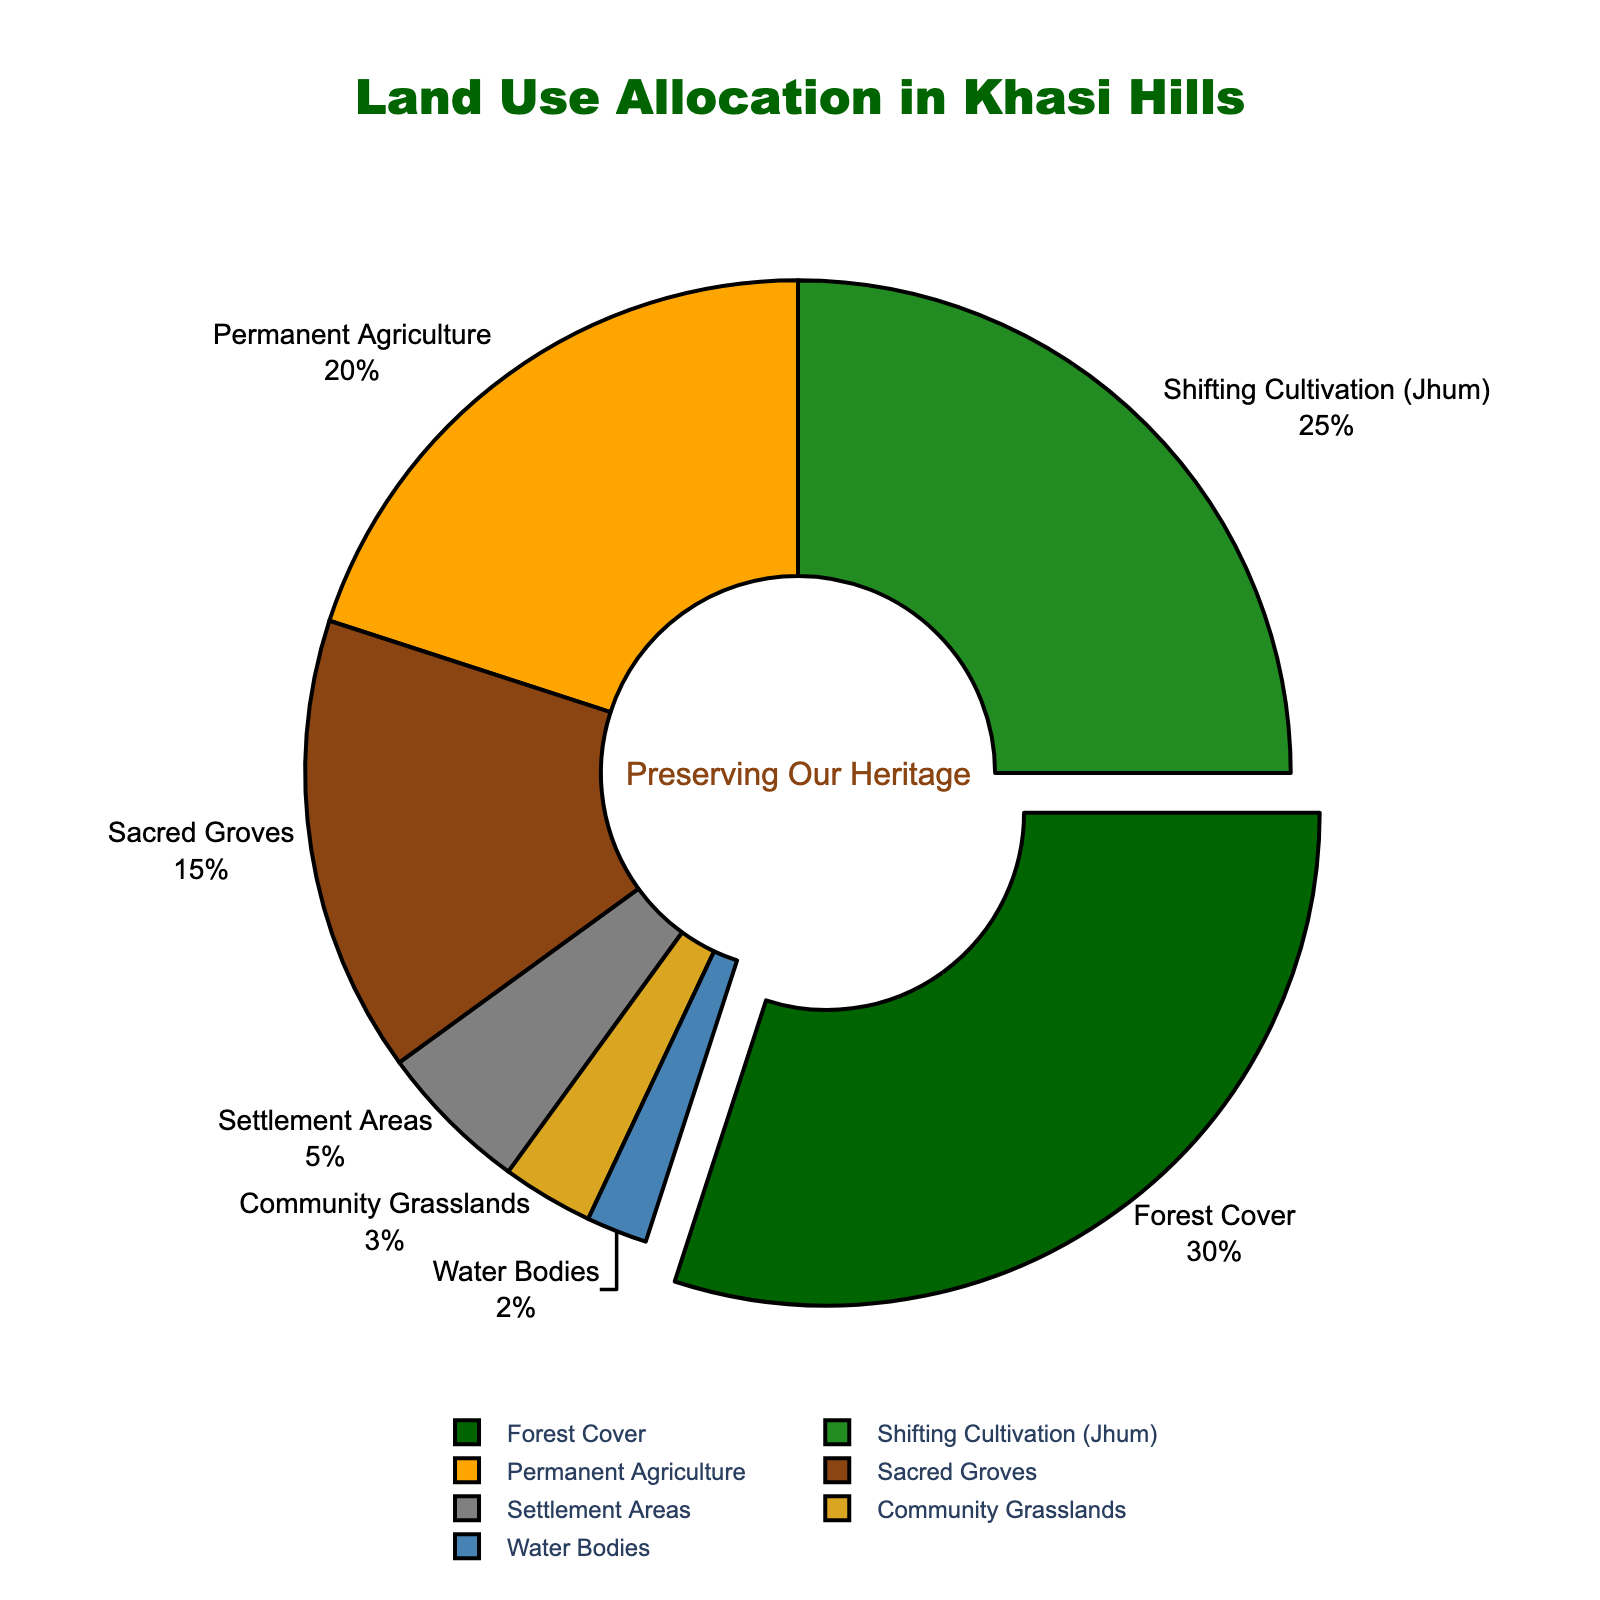Which land use type occupies the largest percentage of the total area? By examining the pie chart, one can identify that the land use type with the largest segment is labeled "Forest Cover". Additionally, this label shows that it occupies 30%. Therefore, "Forest Cover" is the largest.
Answer: Forest Cover How much more percentage is allocated to Shifting Cultivation (Jhum) compared to Settlement Areas? To find the difference, subtract the percentage for Settlement Areas (5%) from the percentage for Shifting Cultivation (Jhum) (25%). The calculation is 25% - 5% = 20%.
Answer: 20% If you combine the areas for Permanent Agriculture and Community Grasslands, what percentage of the total land use does this represent? Adding the percentages for Permanent Agriculture (20%) and Community Grasslands (3%) will give the combined total: 20% + 3% = 23%.
Answer: 23% Which land use types have smaller percentages than Sacred Groves? By comparing the segments, the land use types with smaller percentages than Sacred Groves (15%) are identified as Settlement Areas (5%), Community Grasslands (3%), and Water Bodies (2%).
Answer: Settlement Areas, Community Grasslands, Water Bodies What is the combined percentage of land allocated to sacred groves and water bodies? Adding the percentages for Sacred Groves (15%) and Water Bodies (2%) will give the combined total: 15% + 2% = 17%.
Answer: 17% What percentage of the land is used for agricultural purposes, combining both Shifting Cultivation (Jhum) and Permanent Agriculture? Adding the percentages for Shifting Cultivation (Jhum) (25%) and Permanent Agriculture (20%) will give the combined agricultural land use: 25% + 20% = 45%.
Answer: 45% Between Community Grasslands and Permanent Agriculture, which has a higher land use allocation by how much? By comparing the percentages, Permanent Agriculture (20%) is higher than Community Grasslands (3%). The difference is calculated as 20% - 3% = 17%.
Answer: Permanent Agriculture by 17% What is the total percentage of areas not used for agriculture? The non-agricultural land uses are Sacred Groves (15%), Forest Cover (30%), Settlement Areas (5%), Community Grasslands (3%), Water Bodies (2%). Adding these gives the total non-agricultural land use: 15% + 30% + 5% + 3% + 2% = 55%.
Answer: 55% If the areas allocated to Forest Cover and Sacred Groves were combined, would it exceed the combined areas of Shifting Cultivation (Jhum) and Permanent Agriculture? The combined percentage for Forest Cover and Sacred Groves is 30% + 15% = 45%, and the combined percentage for Shifting Cultivation (Jhum) and Permanent Agriculture is 25% + 20% = 45%. Since both sums are equal, neither combination exceeds the other.
Answer: No 